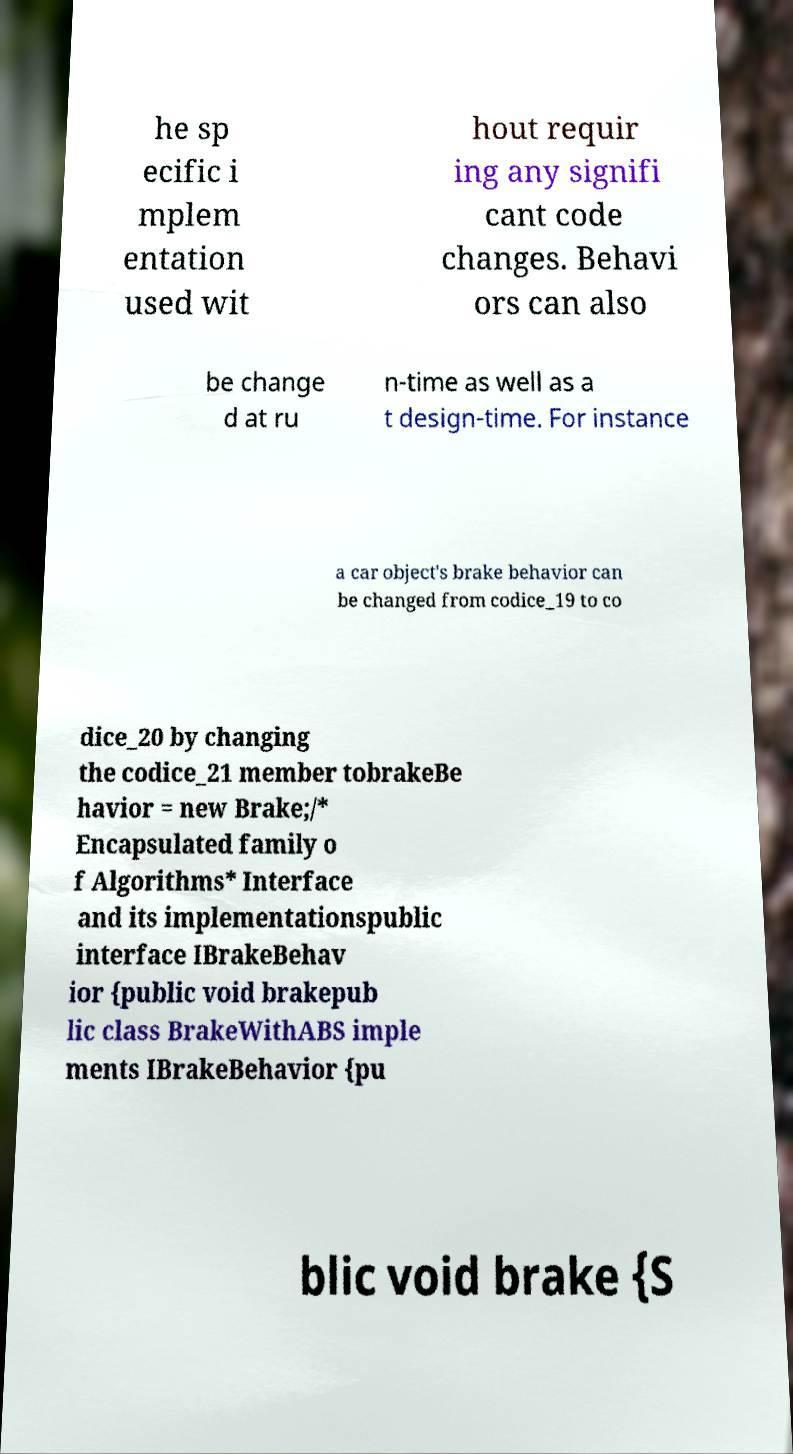For documentation purposes, I need the text within this image transcribed. Could you provide that? he sp ecific i mplem entation used wit hout requir ing any signifi cant code changes. Behavi ors can also be change d at ru n-time as well as a t design-time. For instance a car object's brake behavior can be changed from codice_19 to co dice_20 by changing the codice_21 member tobrakeBe havior = new Brake;/* Encapsulated family o f Algorithms* Interface and its implementationspublic interface IBrakeBehav ior {public void brakepub lic class BrakeWithABS imple ments IBrakeBehavior {pu blic void brake {S 